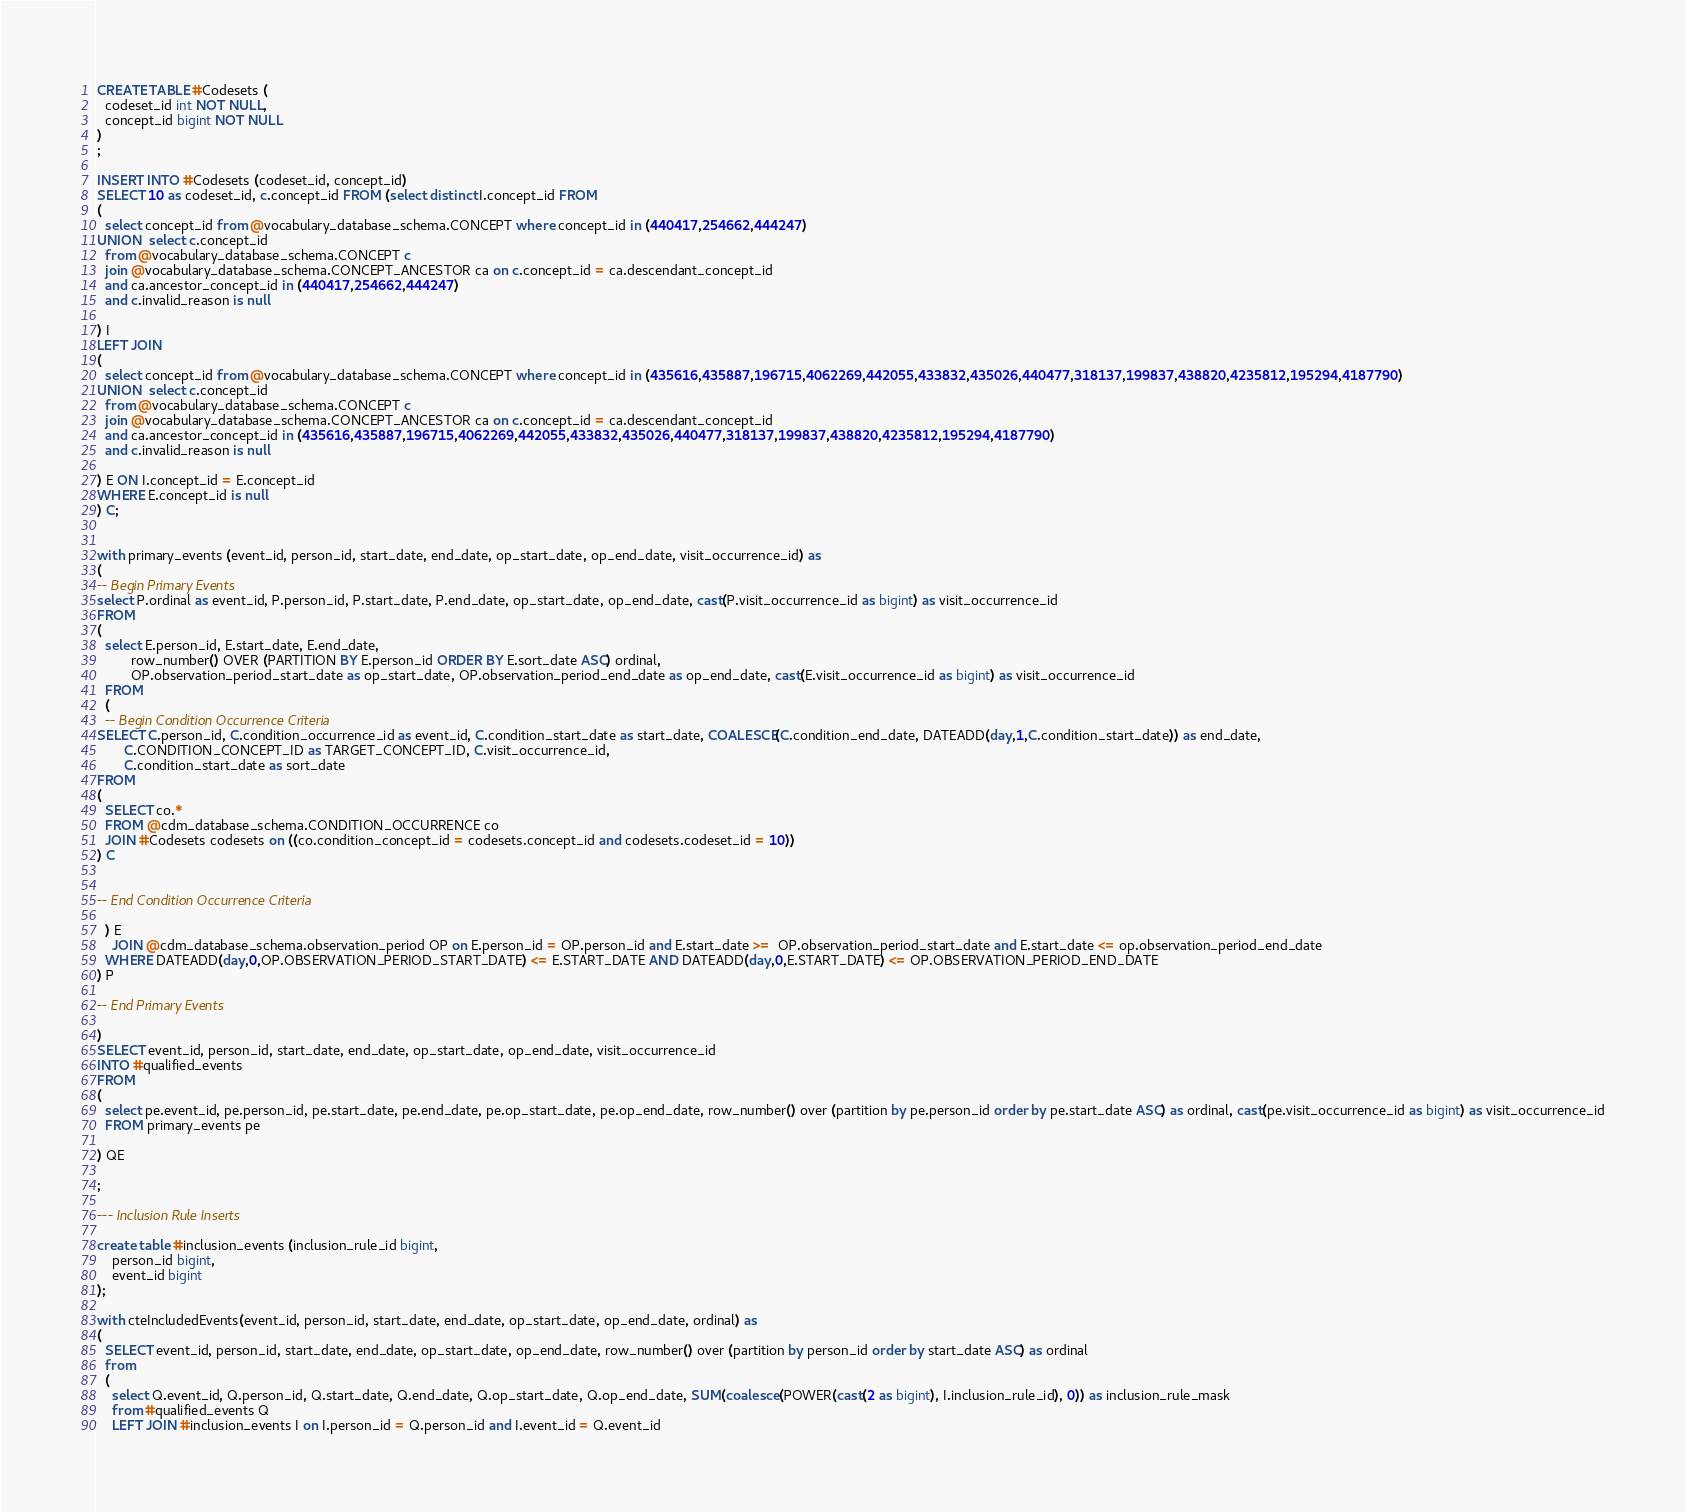<code> <loc_0><loc_0><loc_500><loc_500><_SQL_>CREATE TABLE #Codesets (
  codeset_id int NOT NULL,
  concept_id bigint NOT NULL
)
;

INSERT INTO #Codesets (codeset_id, concept_id)
SELECT 10 as codeset_id, c.concept_id FROM (select distinct I.concept_id FROM
( 
  select concept_id from @vocabulary_database_schema.CONCEPT where concept_id in (440417,254662,444247)
UNION  select c.concept_id
  from @vocabulary_database_schema.CONCEPT c
  join @vocabulary_database_schema.CONCEPT_ANCESTOR ca on c.concept_id = ca.descendant_concept_id
  and ca.ancestor_concept_id in (440417,254662,444247)
  and c.invalid_reason is null

) I
LEFT JOIN
(
  select concept_id from @vocabulary_database_schema.CONCEPT where concept_id in (435616,435887,196715,4062269,442055,433832,435026,440477,318137,199837,438820,4235812,195294,4187790)
UNION  select c.concept_id
  from @vocabulary_database_schema.CONCEPT c
  join @vocabulary_database_schema.CONCEPT_ANCESTOR ca on c.concept_id = ca.descendant_concept_id
  and ca.ancestor_concept_id in (435616,435887,196715,4062269,442055,433832,435026,440477,318137,199837,438820,4235812,195294,4187790)
  and c.invalid_reason is null

) E ON I.concept_id = E.concept_id
WHERE E.concept_id is null
) C;


with primary_events (event_id, person_id, start_date, end_date, op_start_date, op_end_date, visit_occurrence_id) as
(
-- Begin Primary Events
select P.ordinal as event_id, P.person_id, P.start_date, P.end_date, op_start_date, op_end_date, cast(P.visit_occurrence_id as bigint) as visit_occurrence_id
FROM
(
  select E.person_id, E.start_date, E.end_date,
         row_number() OVER (PARTITION BY E.person_id ORDER BY E.sort_date ASC) ordinal,
         OP.observation_period_start_date as op_start_date, OP.observation_period_end_date as op_end_date, cast(E.visit_occurrence_id as bigint) as visit_occurrence_id
  FROM 
  (
  -- Begin Condition Occurrence Criteria
SELECT C.person_id, C.condition_occurrence_id as event_id, C.condition_start_date as start_date, COALESCE(C.condition_end_date, DATEADD(day,1,C.condition_start_date)) as end_date,
       C.CONDITION_CONCEPT_ID as TARGET_CONCEPT_ID, C.visit_occurrence_id,
       C.condition_start_date as sort_date
FROM 
(
  SELECT co.* 
  FROM @cdm_database_schema.CONDITION_OCCURRENCE co
  JOIN #Codesets codesets on ((co.condition_concept_id = codesets.concept_id and codesets.codeset_id = 10))
) C


-- End Condition Occurrence Criteria

  ) E
	JOIN @cdm_database_schema.observation_period OP on E.person_id = OP.person_id and E.start_date >=  OP.observation_period_start_date and E.start_date <= op.observation_period_end_date
  WHERE DATEADD(day,0,OP.OBSERVATION_PERIOD_START_DATE) <= E.START_DATE AND DATEADD(day,0,E.START_DATE) <= OP.OBSERVATION_PERIOD_END_DATE
) P

-- End Primary Events

)
SELECT event_id, person_id, start_date, end_date, op_start_date, op_end_date, visit_occurrence_id
INTO #qualified_events
FROM 
(
  select pe.event_id, pe.person_id, pe.start_date, pe.end_date, pe.op_start_date, pe.op_end_date, row_number() over (partition by pe.person_id order by pe.start_date ASC) as ordinal, cast(pe.visit_occurrence_id as bigint) as visit_occurrence_id
  FROM primary_events pe
  
) QE

;

--- Inclusion Rule Inserts

create table #inclusion_events (inclusion_rule_id bigint,
	person_id bigint,
	event_id bigint
);

with cteIncludedEvents(event_id, person_id, start_date, end_date, op_start_date, op_end_date, ordinal) as
(
  SELECT event_id, person_id, start_date, end_date, op_start_date, op_end_date, row_number() over (partition by person_id order by start_date ASC) as ordinal
  from
  (
    select Q.event_id, Q.person_id, Q.start_date, Q.end_date, Q.op_start_date, Q.op_end_date, SUM(coalesce(POWER(cast(2 as bigint), I.inclusion_rule_id), 0)) as inclusion_rule_mask
    from #qualified_events Q
    LEFT JOIN #inclusion_events I on I.person_id = Q.person_id and I.event_id = Q.event_id</code> 